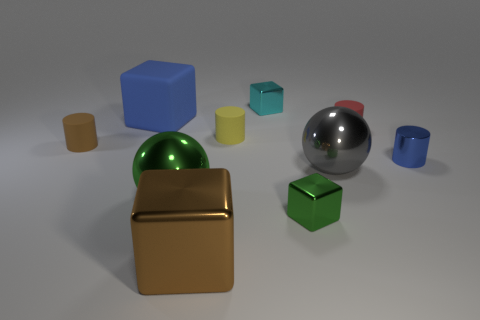How many objects are there in the image, and can you describe their shapes and colors? There are eight objects in the image, including cubes, cylinders, and spheres. Their colors range from gold, blue, cyan, silver, green, to yellow, with varying sizes from small to large. 